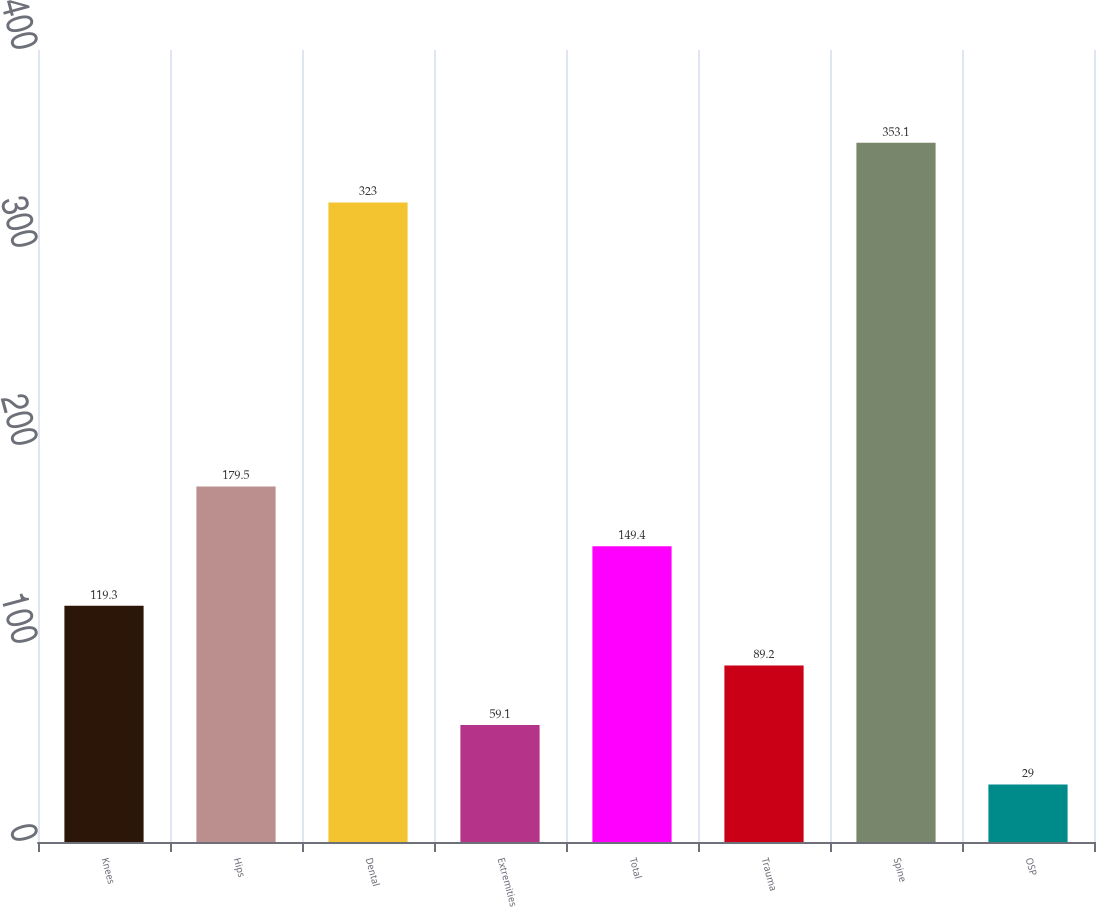<chart> <loc_0><loc_0><loc_500><loc_500><bar_chart><fcel>Knees<fcel>Hips<fcel>Dental<fcel>Extremities<fcel>Total<fcel>Trauma<fcel>Spine<fcel>OSP<nl><fcel>119.3<fcel>179.5<fcel>323<fcel>59.1<fcel>149.4<fcel>89.2<fcel>353.1<fcel>29<nl></chart> 